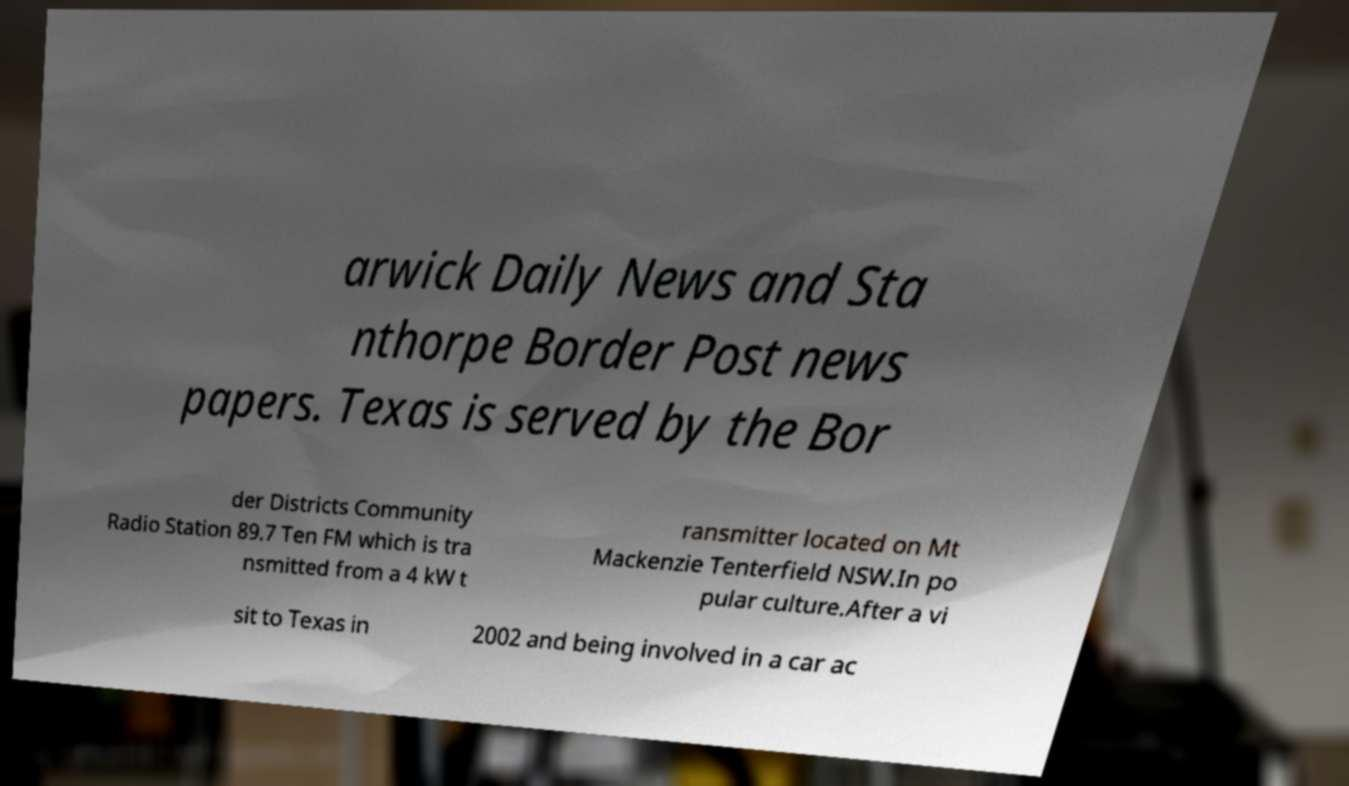Please identify and transcribe the text found in this image. arwick Daily News and Sta nthorpe Border Post news papers. Texas is served by the Bor der Districts Community Radio Station 89.7 Ten FM which is tra nsmitted from a 4 kW t ransmitter located on Mt Mackenzie Tenterfield NSW.In po pular culture.After a vi sit to Texas in 2002 and being involved in a car ac 